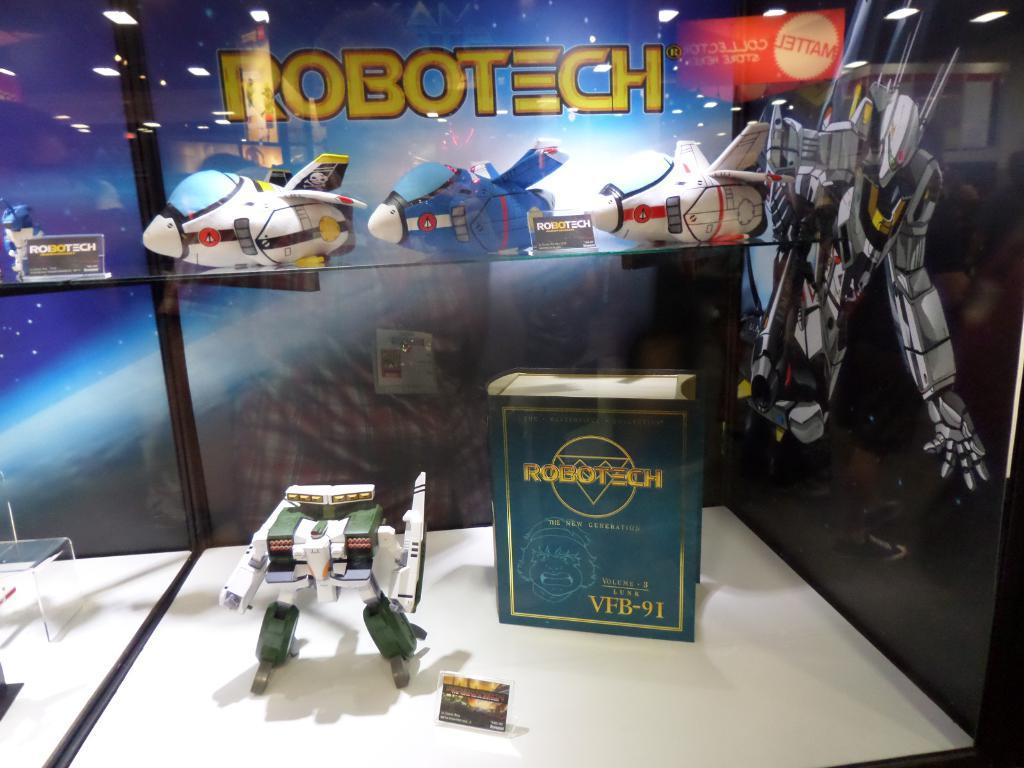What is on the table in the image? There is a book and a toy robot on the table. Are there any other objects on the table? Yes, there are other objects on the table. What can be seen in the background of the image? There are lights, toy planes, a picture of a robot, and text written on the glass in the background. What type of disease is the boy suffering from in the image? There is no boy present in the image, and therefore no information about any diseases. 